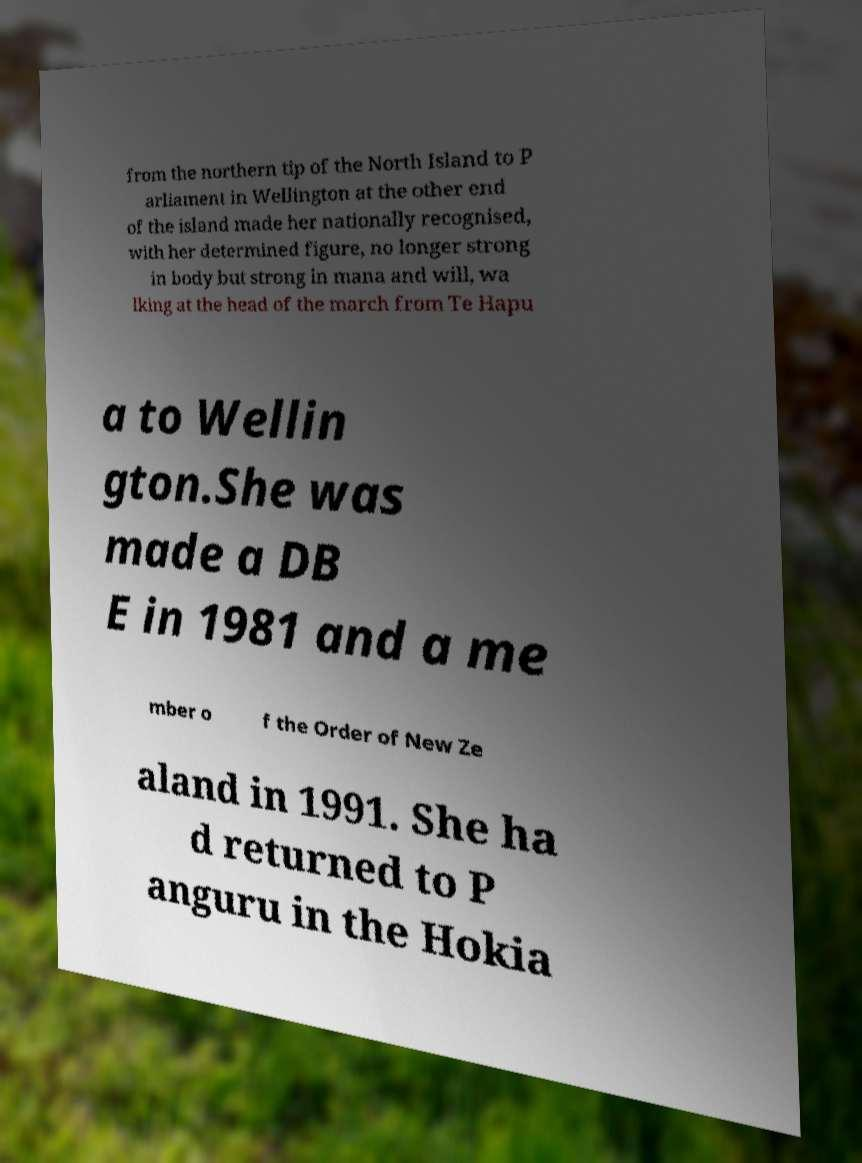I need the written content from this picture converted into text. Can you do that? from the northern tip of the North Island to P arliament in Wellington at the other end of the island made her nationally recognised, with her determined figure, no longer strong in body but strong in mana and will, wa lking at the head of the march from Te Hapu a to Wellin gton.She was made a DB E in 1981 and a me mber o f the Order of New Ze aland in 1991. She ha d returned to P anguru in the Hokia 